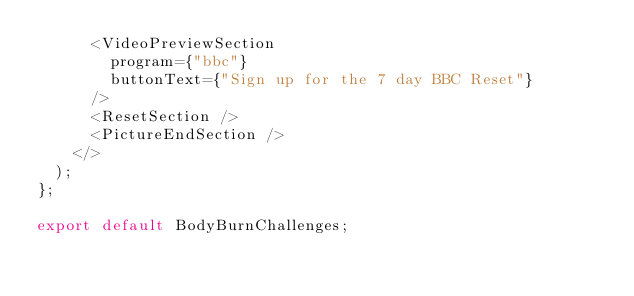Convert code to text. <code><loc_0><loc_0><loc_500><loc_500><_JavaScript_>      <VideoPreviewSection
        program={"bbc"}
        buttonText={"Sign up for the 7 day BBC Reset"}
      />
      <ResetSection />
      <PictureEndSection />
    </>
  );
};

export default BodyBurnChallenges;
</code> 